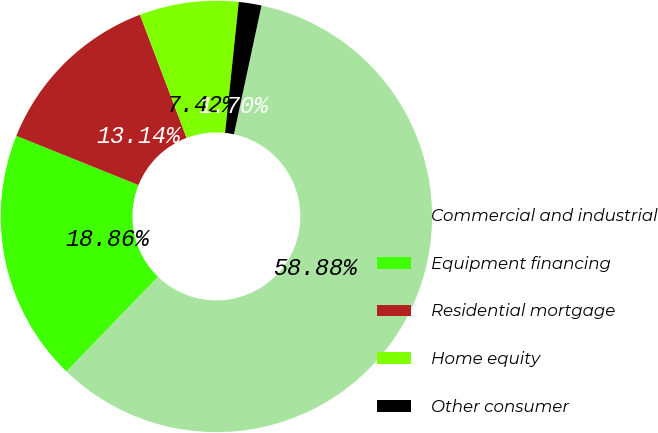Convert chart. <chart><loc_0><loc_0><loc_500><loc_500><pie_chart><fcel>Commercial and industrial<fcel>Equipment financing<fcel>Residential mortgage<fcel>Home equity<fcel>Other consumer<nl><fcel>58.89%<fcel>18.86%<fcel>13.14%<fcel>7.42%<fcel>1.7%<nl></chart> 